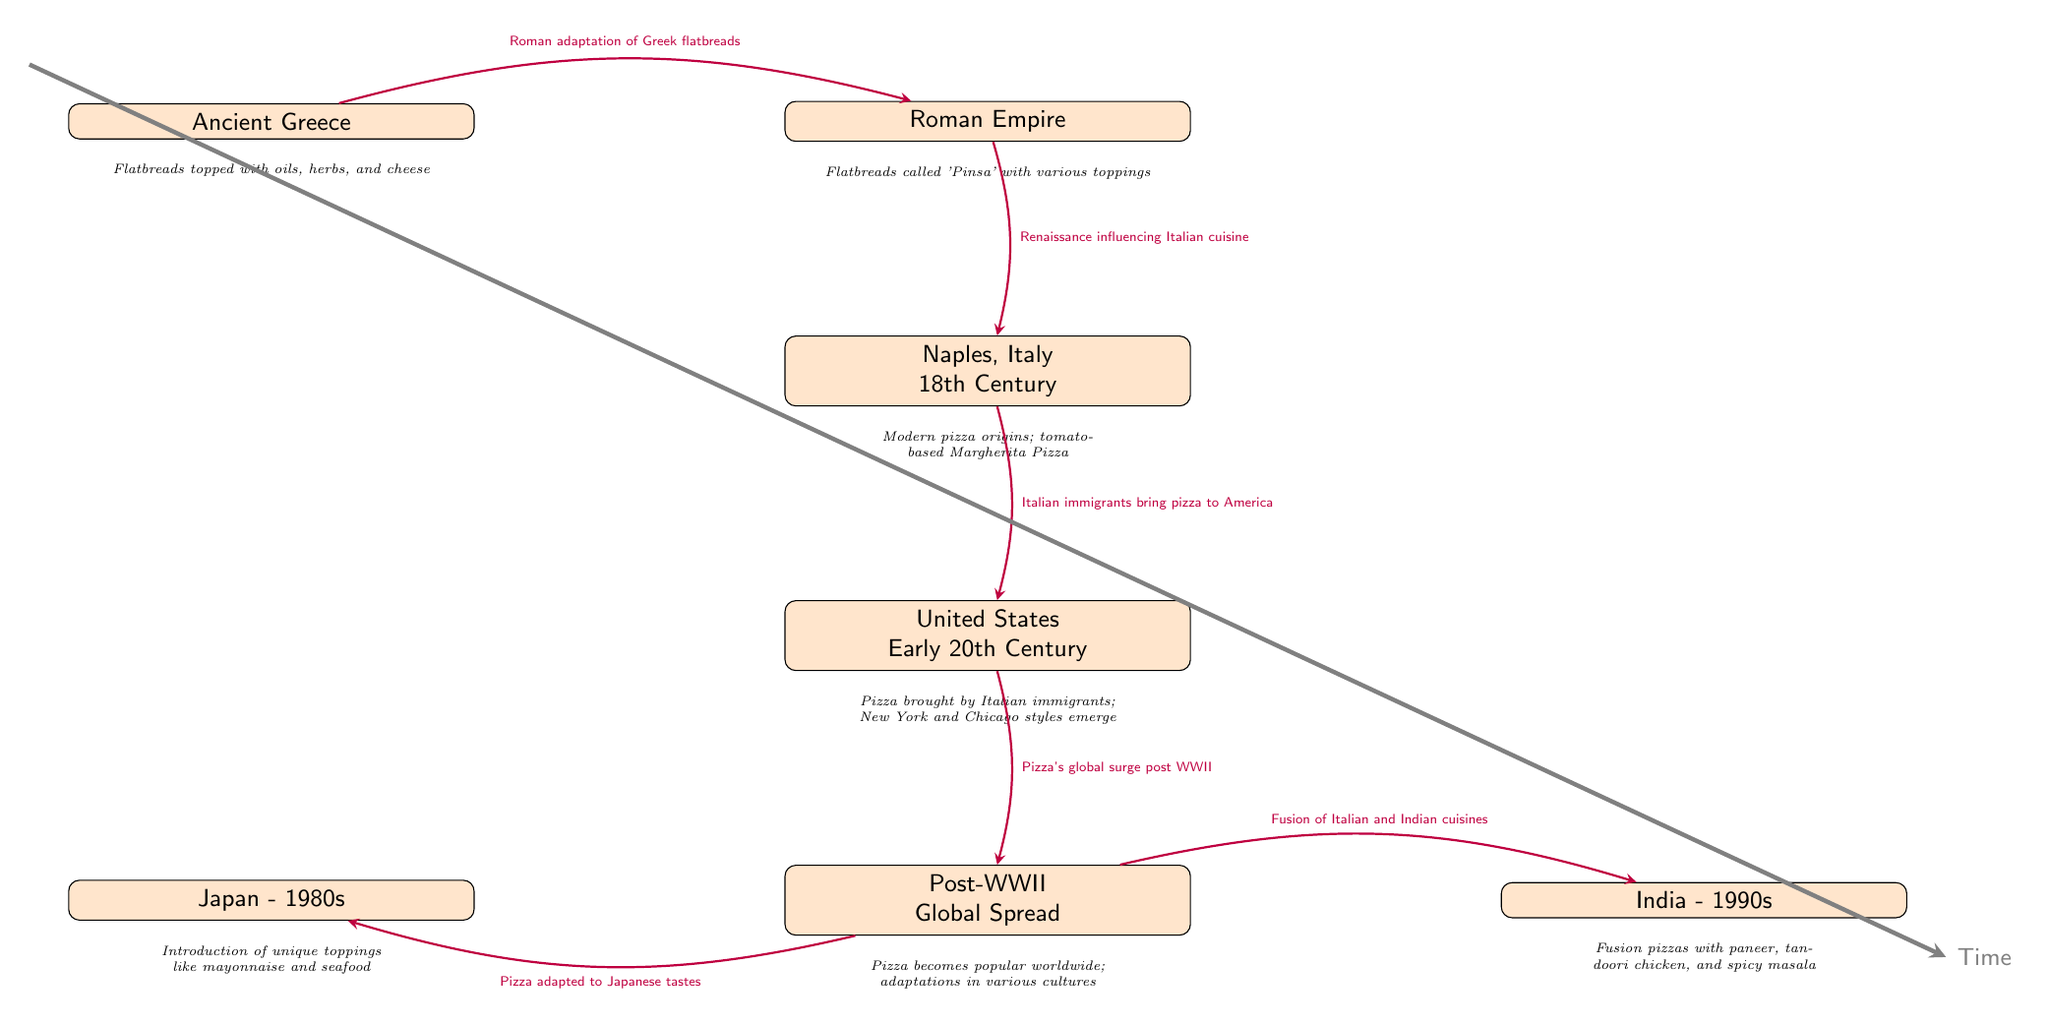What is the earliest point on the timeline? The earliest point on the timeline is "Ancient Greece", which is the first node in the diagram.
Answer: Ancient Greece How many nodes are in the timeline? By counting the distinct events labeled in the diagram, there are 7 nodes.
Answer: 7 What topping made Naples, Italy's pizza modern? The description under Naples, Italy states that the modern pizza origins include "tomato-based Margherita Pizza."
Answer: tomato-based Margherita Pizza Which country introduced pizza adaptations in the 1980s? The diagram identifies that Japan is the country associated with adapting pizza in the 1980s.
Answer: Japan What is the significant event related to pizza in the United States? The connection labeled from Naples to the United States specifies that "Pizza brought by Italian immigrants" is significant in this context.
Answer: Italian immigrants What do fusion pizzas in India include? The description associated with India in the 1990s lists toppings like "paneer, tandoori chicken, and spicy masala" for their fusion pizzas.
Answer: paneer, tandoori chicken, and spicy masala What historical period led to pizza's global popularity? The timeline shows that the post-WWII era signifies this boom in pizza's global popularity.
Answer: Post-WWII What influence did the Roman Empire have on pizza? The diagram indicates that the Roman Empire was responsible for the "Roman adaptation of Greek flatbreads" which influenced pizza's evolution.
Answer: Roman adaptation of Greek flatbreads Which two countries adapted pizza after its global surge? The arrows indicate that Japan and India both adapted pizza following its global surge, as noted in the post-WWII node description.
Answer: Japan and India 